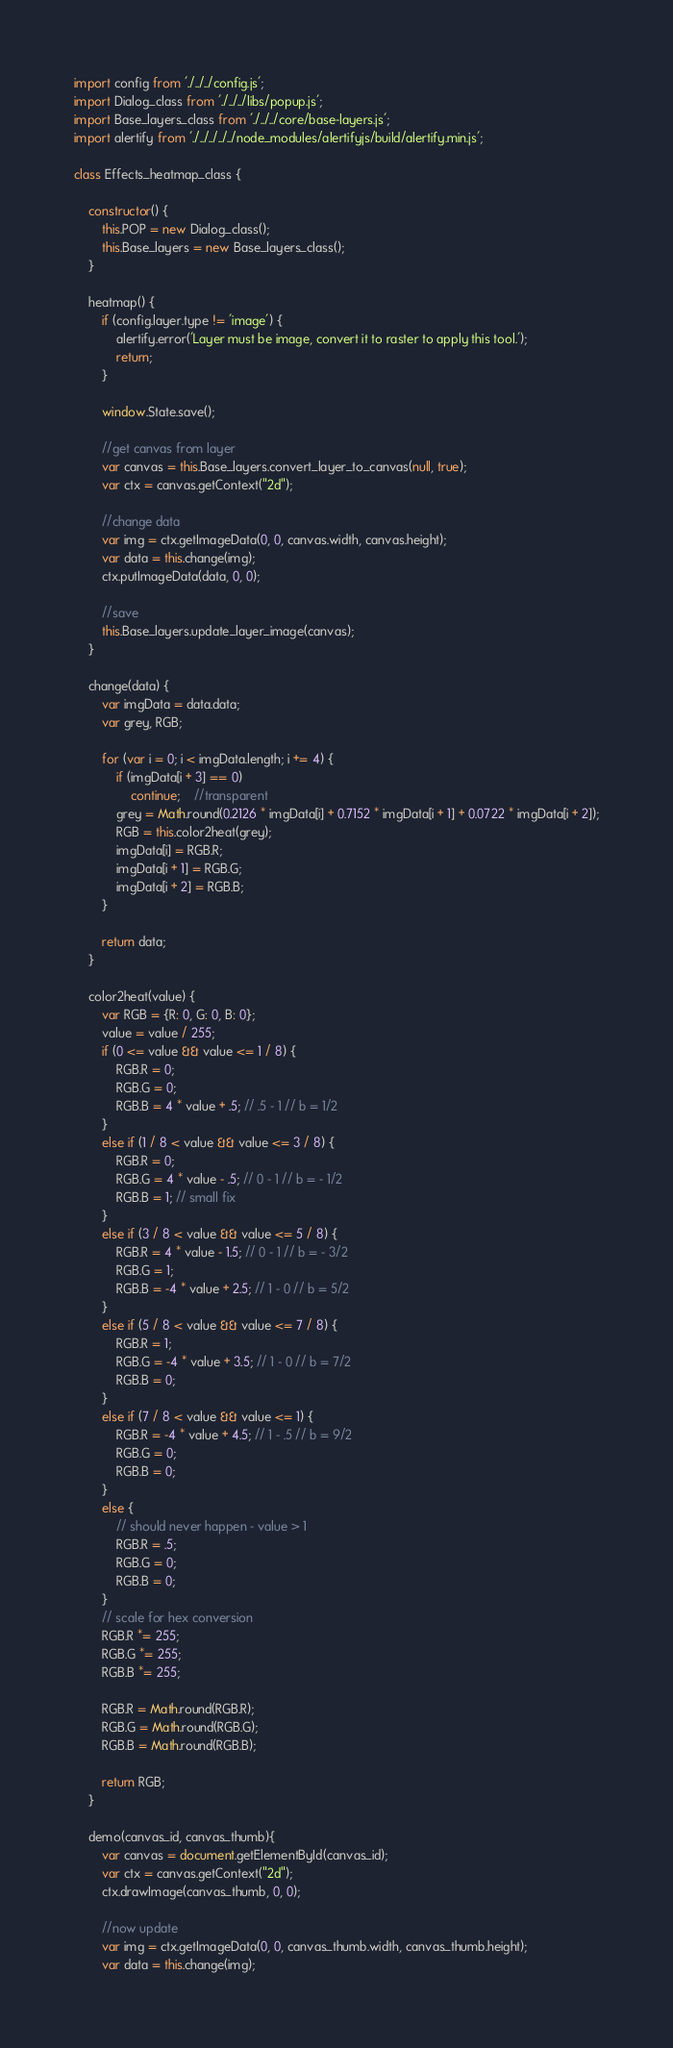<code> <loc_0><loc_0><loc_500><loc_500><_JavaScript_>import config from './../../config.js';
import Dialog_class from './../../libs/popup.js';
import Base_layers_class from './../../core/base-layers.js';
import alertify from './../../../../node_modules/alertifyjs/build/alertify.min.js';

class Effects_heatmap_class {

	constructor() {
		this.POP = new Dialog_class();
		this.Base_layers = new Base_layers_class();
	}

	heatmap() {
		if (config.layer.type != 'image') {
			alertify.error('Layer must be image, convert it to raster to apply this tool.');
			return;
		}

		window.State.save();

		//get canvas from layer
		var canvas = this.Base_layers.convert_layer_to_canvas(null, true);
		var ctx = canvas.getContext("2d");

		//change data
		var img = ctx.getImageData(0, 0, canvas.width, canvas.height);
		var data = this.change(img);
		ctx.putImageData(data, 0, 0);

		//save
		this.Base_layers.update_layer_image(canvas);
	}

	change(data) {
		var imgData = data.data;
		var grey, RGB;

		for (var i = 0; i < imgData.length; i += 4) {
			if (imgData[i + 3] == 0)
				continue;	//transparent
			grey = Math.round(0.2126 * imgData[i] + 0.7152 * imgData[i + 1] + 0.0722 * imgData[i + 2]);
			RGB = this.color2heat(grey);
			imgData[i] = RGB.R;
			imgData[i + 1] = RGB.G;
			imgData[i + 2] = RGB.B;
		}

		return data;
	}

	color2heat(value) {
		var RGB = {R: 0, G: 0, B: 0};
		value = value / 255;
		if (0 <= value && value <= 1 / 8) {
			RGB.R = 0;
			RGB.G = 0;
			RGB.B = 4 * value + .5; // .5 - 1 // b = 1/2
		}
		else if (1 / 8 < value && value <= 3 / 8) {
			RGB.R = 0;
			RGB.G = 4 * value - .5; // 0 - 1 // b = - 1/2
			RGB.B = 1; // small fix
		}
		else if (3 / 8 < value && value <= 5 / 8) {
			RGB.R = 4 * value - 1.5; // 0 - 1 // b = - 3/2
			RGB.G = 1;
			RGB.B = -4 * value + 2.5; // 1 - 0 // b = 5/2
		}
		else if (5 / 8 < value && value <= 7 / 8) {
			RGB.R = 1;
			RGB.G = -4 * value + 3.5; // 1 - 0 // b = 7/2
			RGB.B = 0;
		}
		else if (7 / 8 < value && value <= 1) {
			RGB.R = -4 * value + 4.5; // 1 - .5 // b = 9/2
			RGB.G = 0;
			RGB.B = 0;
		}
		else {
			// should never happen - value > 1
			RGB.R = .5;
			RGB.G = 0;
			RGB.B = 0;
		}
		// scale for hex conversion
		RGB.R *= 255;
		RGB.G *= 255;
		RGB.B *= 255;

		RGB.R = Math.round(RGB.R);
		RGB.G = Math.round(RGB.G);
		RGB.B = Math.round(RGB.B);

		return RGB;
	}

	demo(canvas_id, canvas_thumb){
		var canvas = document.getElementById(canvas_id);
		var ctx = canvas.getContext("2d");
		ctx.drawImage(canvas_thumb, 0, 0);

		//now update
		var img = ctx.getImageData(0, 0, canvas_thumb.width, canvas_thumb.height);
		var data = this.change(img);</code> 